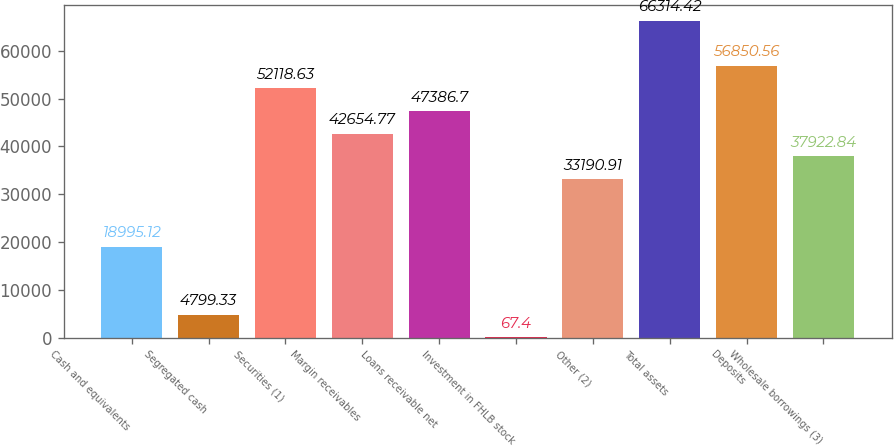Convert chart to OTSL. <chart><loc_0><loc_0><loc_500><loc_500><bar_chart><fcel>Cash and equivalents<fcel>Segregated cash<fcel>Securities (1)<fcel>Margin receivables<fcel>Loans receivable net<fcel>Investment in FHLB stock<fcel>Other (2)<fcel>Total assets<fcel>Deposits<fcel>Wholesale borrowings (3)<nl><fcel>18995.1<fcel>4799.33<fcel>52118.6<fcel>42654.8<fcel>47386.7<fcel>67.4<fcel>33190.9<fcel>66314.4<fcel>56850.6<fcel>37922.8<nl></chart> 